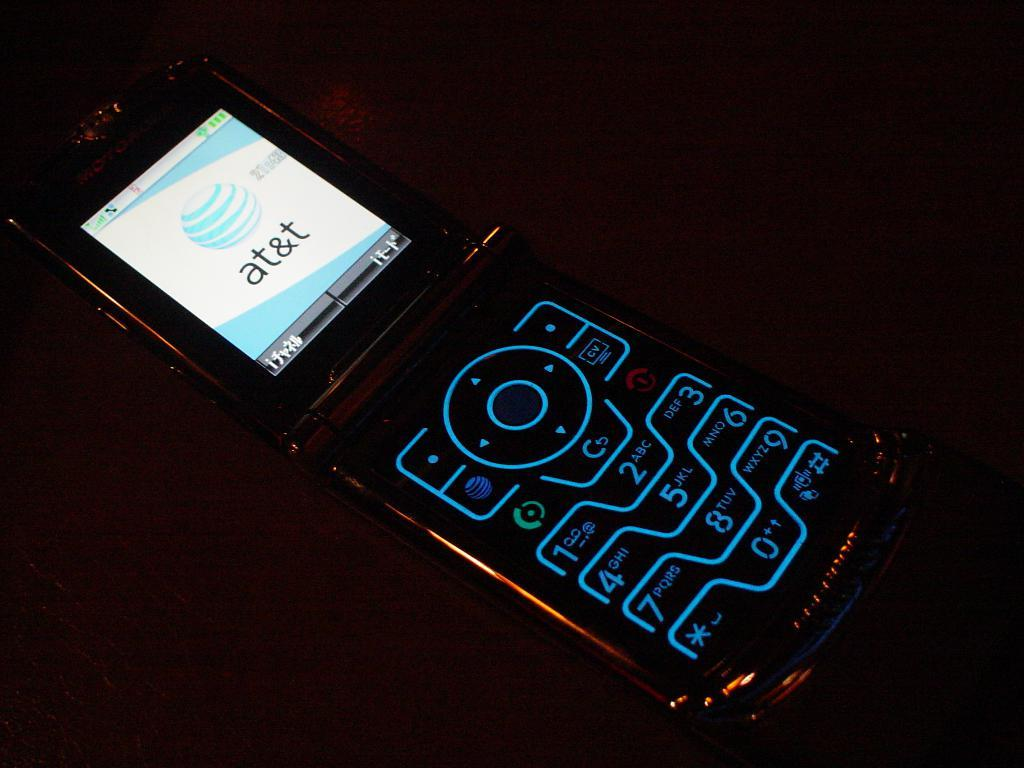<image>
Render a clear and concise summary of the photo. A flip phone is lit with bluish tint and the screen says AT&T. 